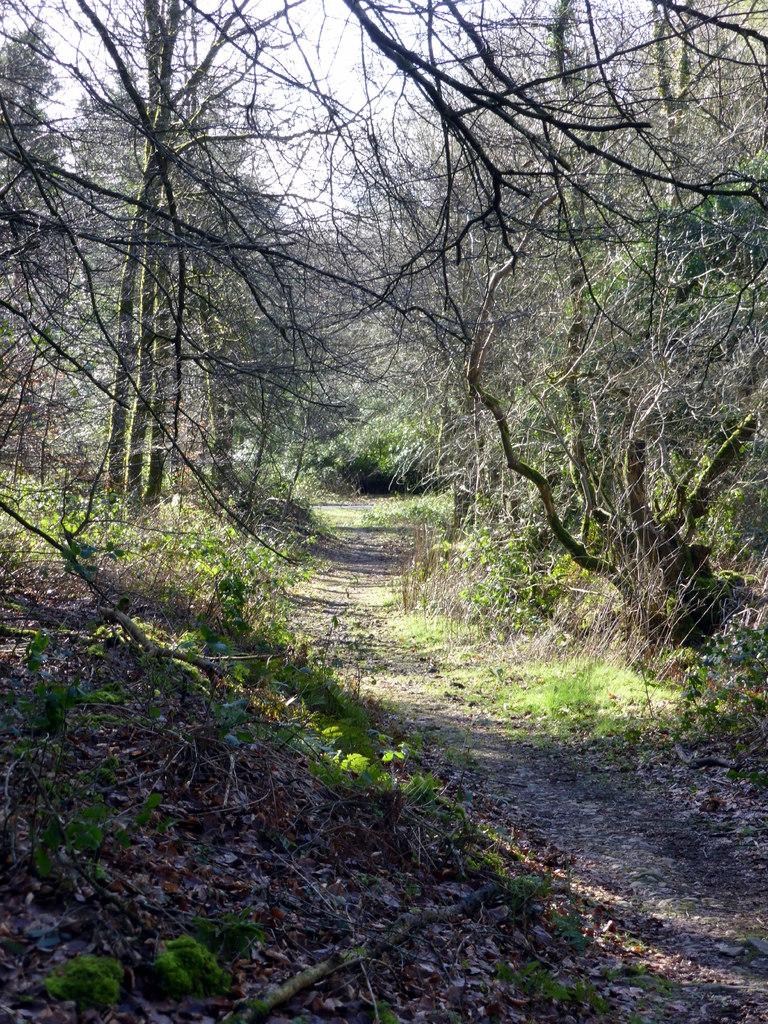What type of vegetation can be seen in the image? There are trees in the image. What type of ground cover is present in the image? There is grass in the image. What feature is located in the middle of the image? There is a pathway in the middle of the image. What note is the fireman playing on his trumpet in the image? There is no fireman or trumpet present in the image. 